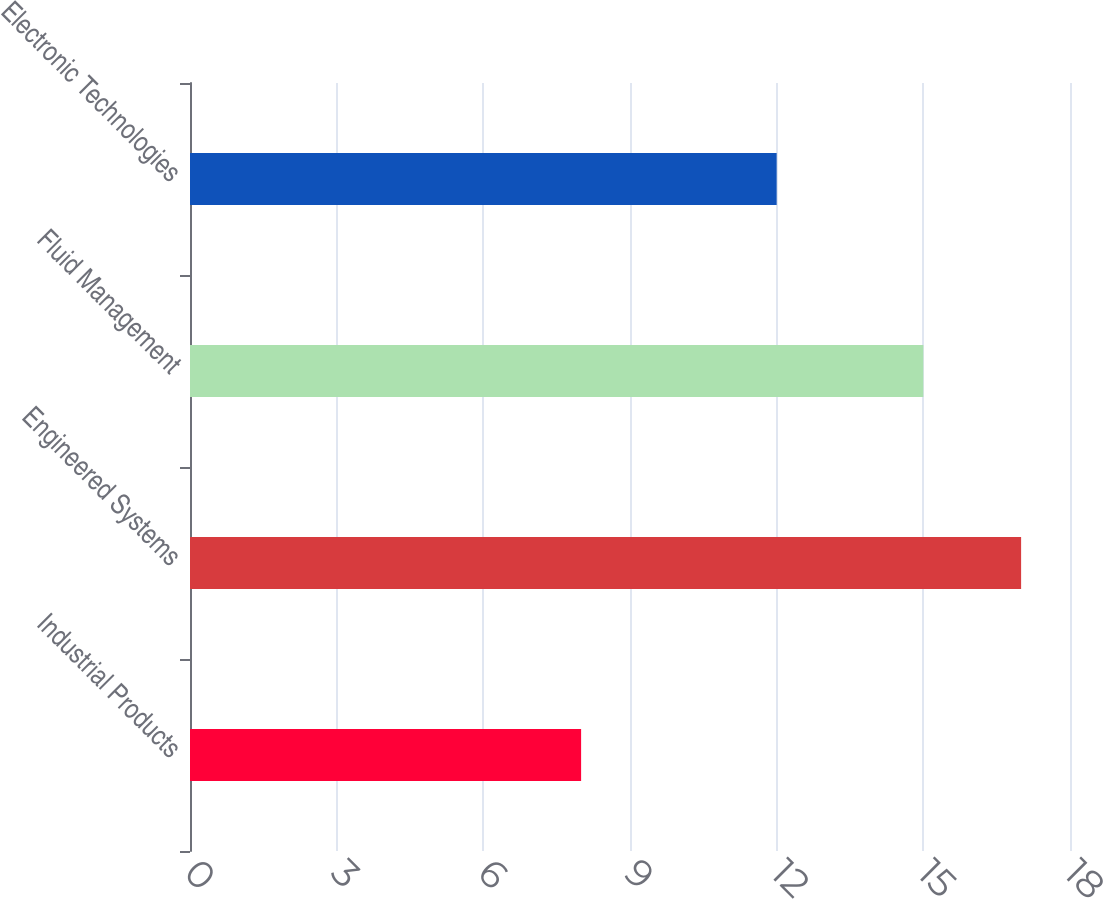<chart> <loc_0><loc_0><loc_500><loc_500><bar_chart><fcel>Industrial Products<fcel>Engineered Systems<fcel>Fluid Management<fcel>Electronic Technologies<nl><fcel>8<fcel>17<fcel>15<fcel>12<nl></chart> 